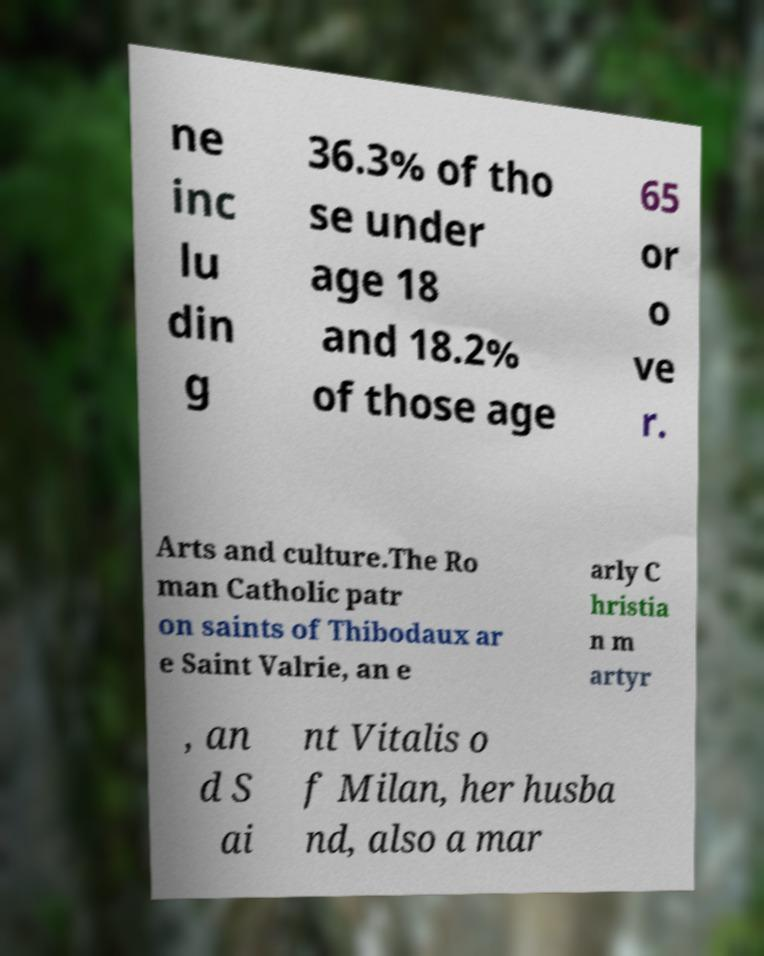Can you accurately transcribe the text from the provided image for me? ne inc lu din g 36.3% of tho se under age 18 and 18.2% of those age 65 or o ve r. Arts and culture.The Ro man Catholic patr on saints of Thibodaux ar e Saint Valrie, an e arly C hristia n m artyr , an d S ai nt Vitalis o f Milan, her husba nd, also a mar 